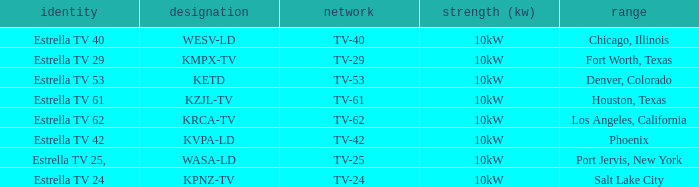List the branding name for channel tv-62. Estrella TV 62. 